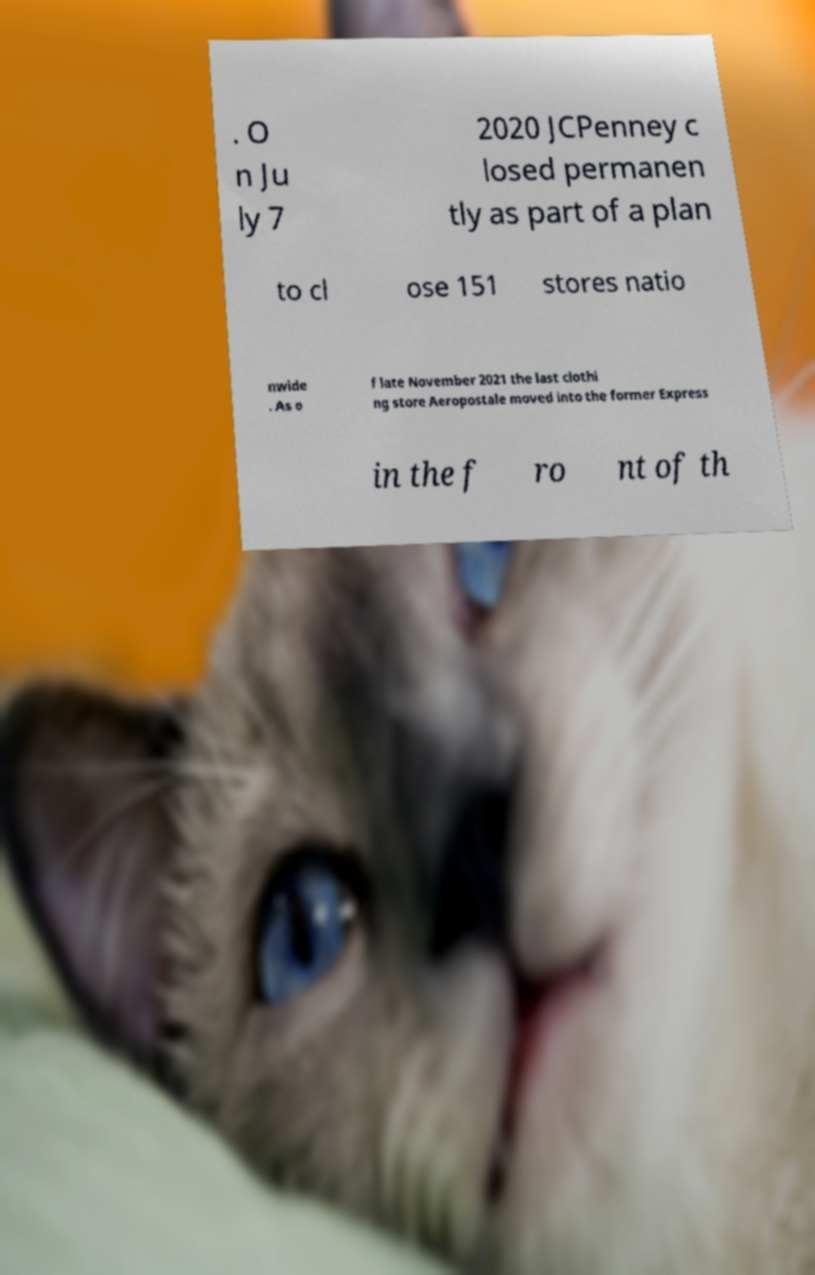For documentation purposes, I need the text within this image transcribed. Could you provide that? . O n Ju ly 7 2020 JCPenney c losed permanen tly as part of a plan to cl ose 151 stores natio nwide . As o f late November 2021 the last clothi ng store Aeropostale moved into the former Express in the f ro nt of th 